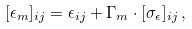<formula> <loc_0><loc_0><loc_500><loc_500>[ \epsilon _ { m } ] _ { i j } = \epsilon _ { i j } + \Gamma _ { m } \cdot [ \sigma _ { \epsilon } ] _ { i j } \, ,</formula> 